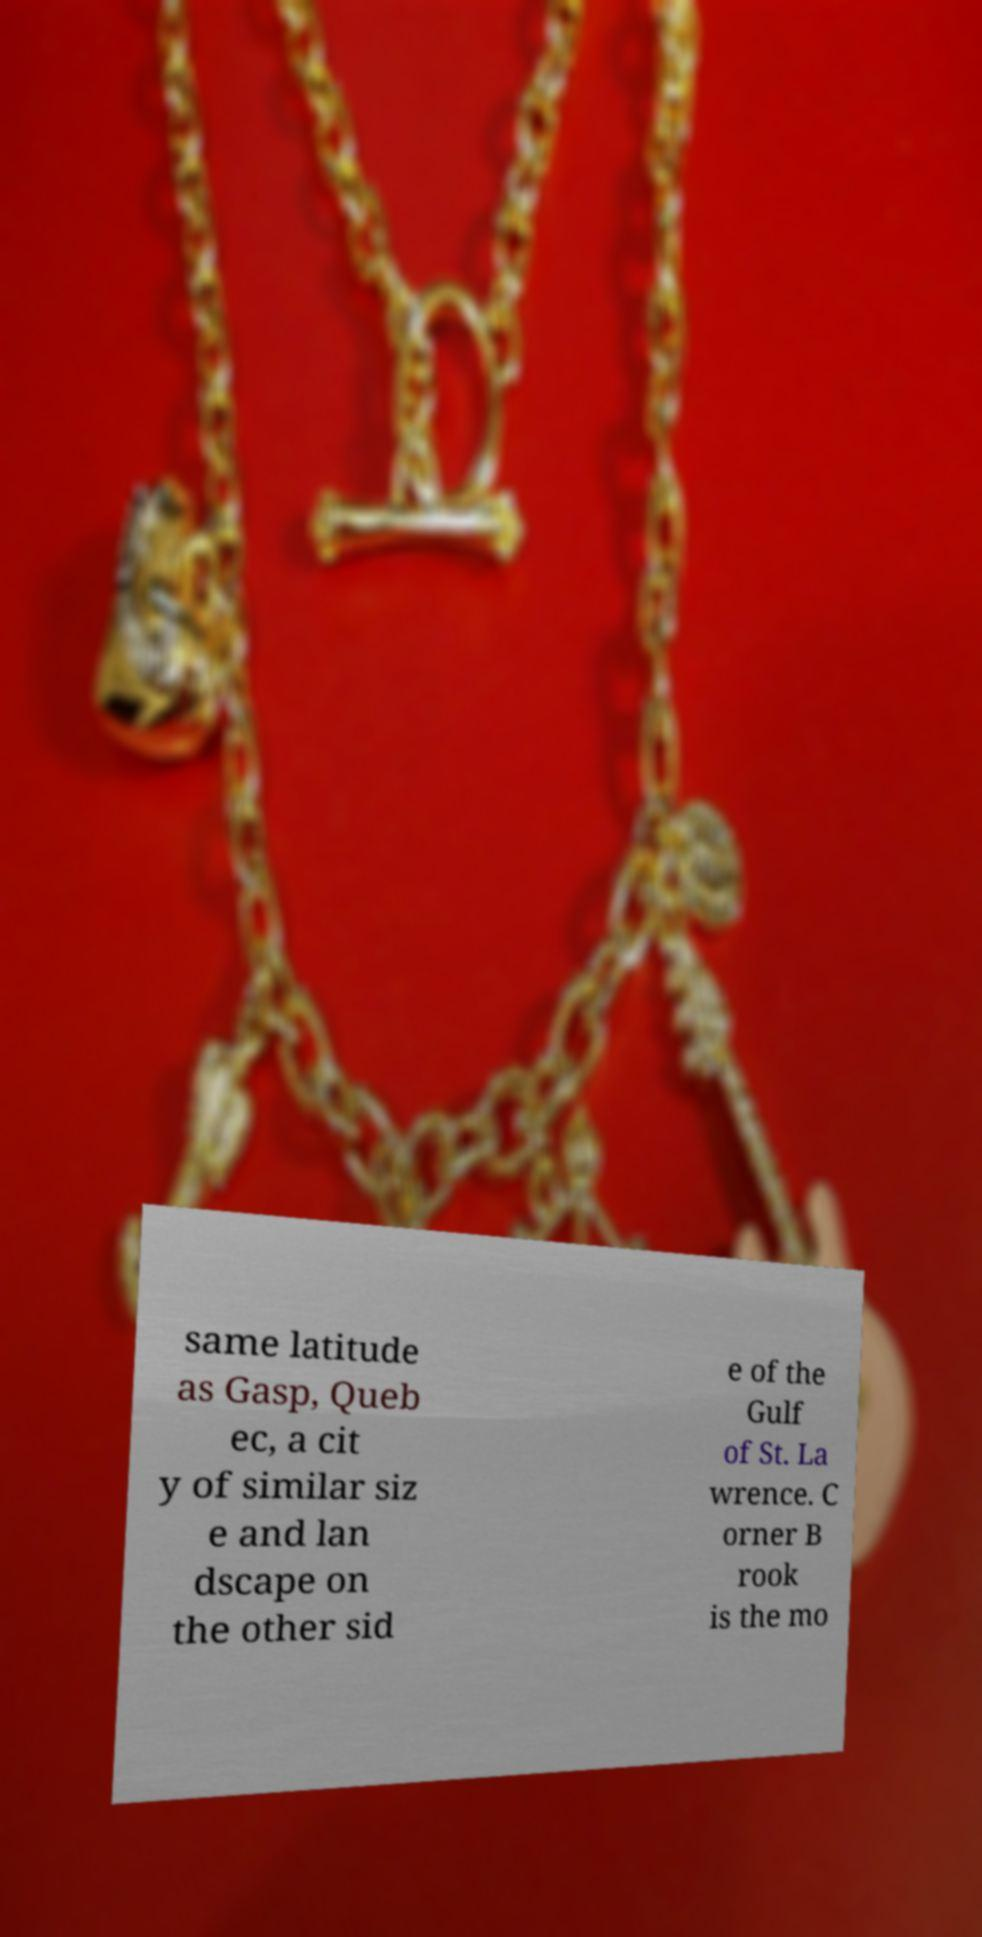Can you accurately transcribe the text from the provided image for me? same latitude as Gasp, Queb ec, a cit y of similar siz e and lan dscape on the other sid e of the Gulf of St. La wrence. C orner B rook is the mo 